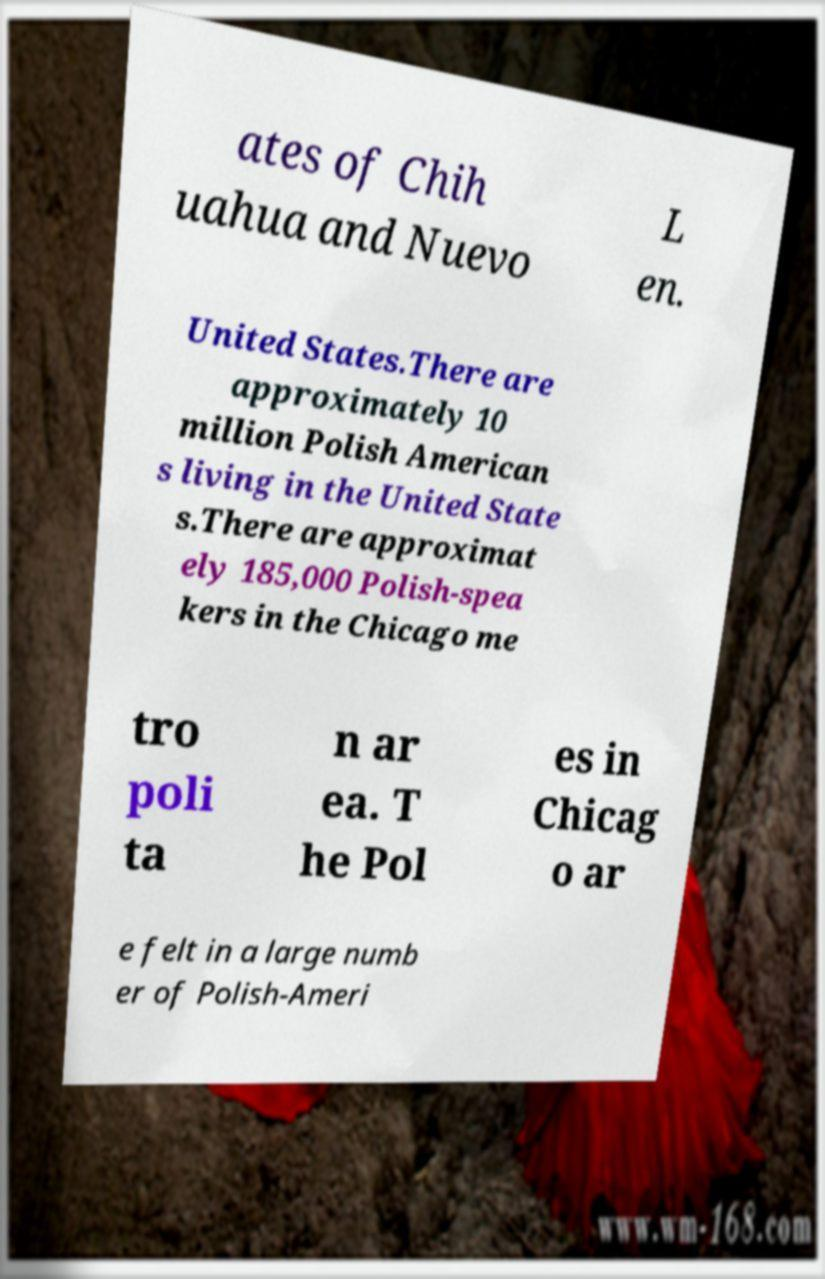What messages or text are displayed in this image? I need them in a readable, typed format. ates of Chih uahua and Nuevo L en. United States.There are approximately 10 million Polish American s living in the United State s.There are approximat ely 185,000 Polish-spea kers in the Chicago me tro poli ta n ar ea. T he Pol es in Chicag o ar e felt in a large numb er of Polish-Ameri 